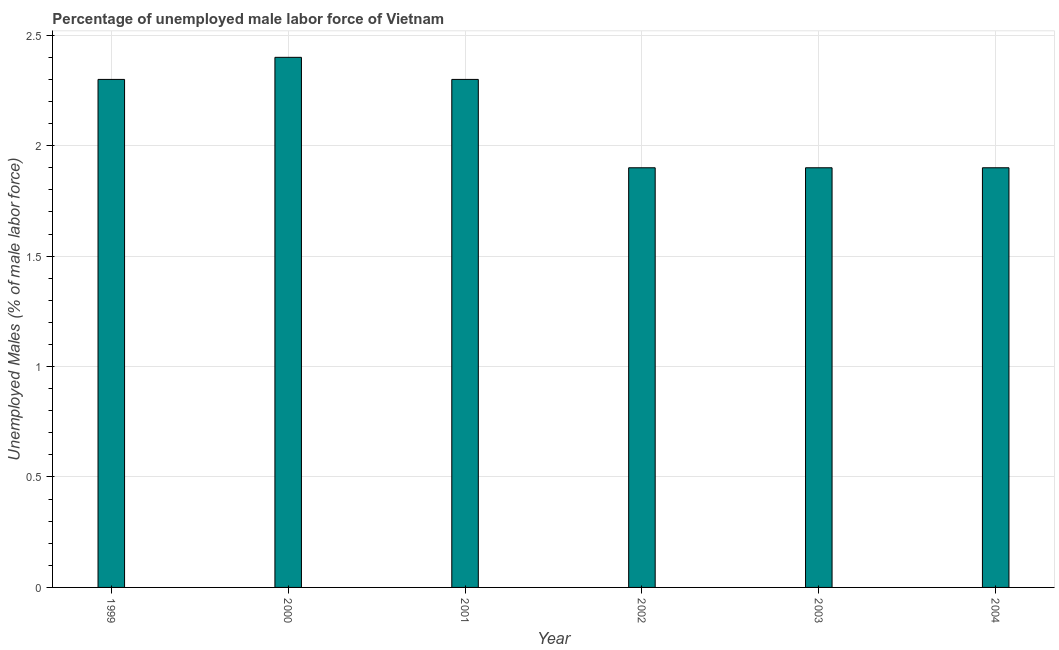Does the graph contain any zero values?
Ensure brevity in your answer.  No. Does the graph contain grids?
Keep it short and to the point. Yes. What is the title of the graph?
Offer a very short reply. Percentage of unemployed male labor force of Vietnam. What is the label or title of the X-axis?
Your answer should be compact. Year. What is the label or title of the Y-axis?
Your answer should be compact. Unemployed Males (% of male labor force). What is the total unemployed male labour force in 2001?
Make the answer very short. 2.3. Across all years, what is the maximum total unemployed male labour force?
Your answer should be very brief. 2.4. Across all years, what is the minimum total unemployed male labour force?
Provide a succinct answer. 1.9. In which year was the total unemployed male labour force maximum?
Make the answer very short. 2000. In which year was the total unemployed male labour force minimum?
Your response must be concise. 2002. What is the sum of the total unemployed male labour force?
Ensure brevity in your answer.  12.7. What is the difference between the total unemployed male labour force in 2002 and 2004?
Offer a terse response. 0. What is the average total unemployed male labour force per year?
Your response must be concise. 2.12. What is the median total unemployed male labour force?
Your answer should be very brief. 2.1. What is the ratio of the total unemployed male labour force in 2000 to that in 2004?
Provide a short and direct response. 1.26. Is the total unemployed male labour force in 2000 less than that in 2003?
Ensure brevity in your answer.  No. What is the difference between the highest and the lowest total unemployed male labour force?
Ensure brevity in your answer.  0.5. In how many years, is the total unemployed male labour force greater than the average total unemployed male labour force taken over all years?
Ensure brevity in your answer.  3. Are all the bars in the graph horizontal?
Your response must be concise. No. How many years are there in the graph?
Your answer should be compact. 6. Are the values on the major ticks of Y-axis written in scientific E-notation?
Provide a succinct answer. No. What is the Unemployed Males (% of male labor force) of 1999?
Offer a very short reply. 2.3. What is the Unemployed Males (% of male labor force) in 2000?
Keep it short and to the point. 2.4. What is the Unemployed Males (% of male labor force) in 2001?
Offer a terse response. 2.3. What is the Unemployed Males (% of male labor force) in 2002?
Provide a short and direct response. 1.9. What is the Unemployed Males (% of male labor force) of 2003?
Keep it short and to the point. 1.9. What is the Unemployed Males (% of male labor force) of 2004?
Offer a very short reply. 1.9. What is the difference between the Unemployed Males (% of male labor force) in 1999 and 2000?
Provide a succinct answer. -0.1. What is the difference between the Unemployed Males (% of male labor force) in 1999 and 2001?
Offer a terse response. 0. What is the difference between the Unemployed Males (% of male labor force) in 1999 and 2002?
Give a very brief answer. 0.4. What is the difference between the Unemployed Males (% of male labor force) in 2000 and 2001?
Give a very brief answer. 0.1. What is the difference between the Unemployed Males (% of male labor force) in 2000 and 2002?
Offer a very short reply. 0.5. What is the difference between the Unemployed Males (% of male labor force) in 2001 and 2004?
Offer a very short reply. 0.4. What is the difference between the Unemployed Males (% of male labor force) in 2002 and 2003?
Provide a short and direct response. 0. What is the difference between the Unemployed Males (% of male labor force) in 2002 and 2004?
Keep it short and to the point. 0. What is the ratio of the Unemployed Males (% of male labor force) in 1999 to that in 2000?
Give a very brief answer. 0.96. What is the ratio of the Unemployed Males (% of male labor force) in 1999 to that in 2001?
Give a very brief answer. 1. What is the ratio of the Unemployed Males (% of male labor force) in 1999 to that in 2002?
Make the answer very short. 1.21. What is the ratio of the Unemployed Males (% of male labor force) in 1999 to that in 2003?
Keep it short and to the point. 1.21. What is the ratio of the Unemployed Males (% of male labor force) in 1999 to that in 2004?
Offer a very short reply. 1.21. What is the ratio of the Unemployed Males (% of male labor force) in 2000 to that in 2001?
Offer a terse response. 1.04. What is the ratio of the Unemployed Males (% of male labor force) in 2000 to that in 2002?
Make the answer very short. 1.26. What is the ratio of the Unemployed Males (% of male labor force) in 2000 to that in 2003?
Provide a short and direct response. 1.26. What is the ratio of the Unemployed Males (% of male labor force) in 2000 to that in 2004?
Your answer should be compact. 1.26. What is the ratio of the Unemployed Males (% of male labor force) in 2001 to that in 2002?
Make the answer very short. 1.21. What is the ratio of the Unemployed Males (% of male labor force) in 2001 to that in 2003?
Provide a short and direct response. 1.21. What is the ratio of the Unemployed Males (% of male labor force) in 2001 to that in 2004?
Offer a very short reply. 1.21. What is the ratio of the Unemployed Males (% of male labor force) in 2002 to that in 2003?
Offer a very short reply. 1. What is the ratio of the Unemployed Males (% of male labor force) in 2002 to that in 2004?
Provide a succinct answer. 1. What is the ratio of the Unemployed Males (% of male labor force) in 2003 to that in 2004?
Offer a very short reply. 1. 